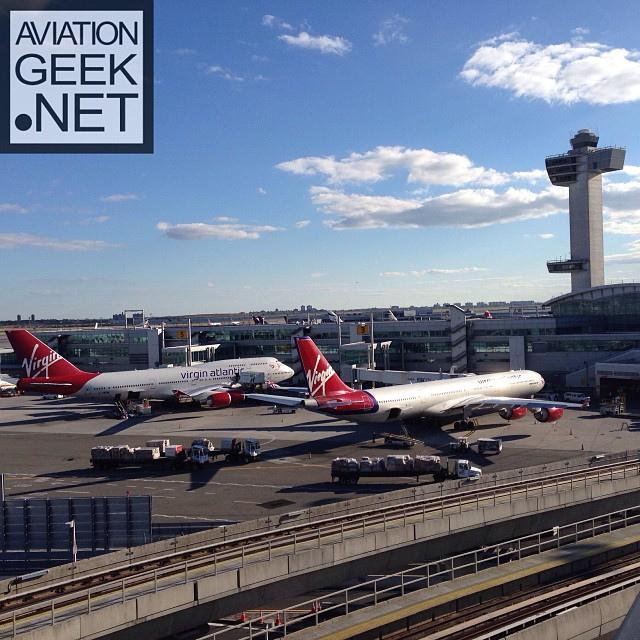What other item did the company whose name appears on the large vehicle make?

Choices:
A) hot dogs
B) televisions
C) phones
D) hamburgers phones 